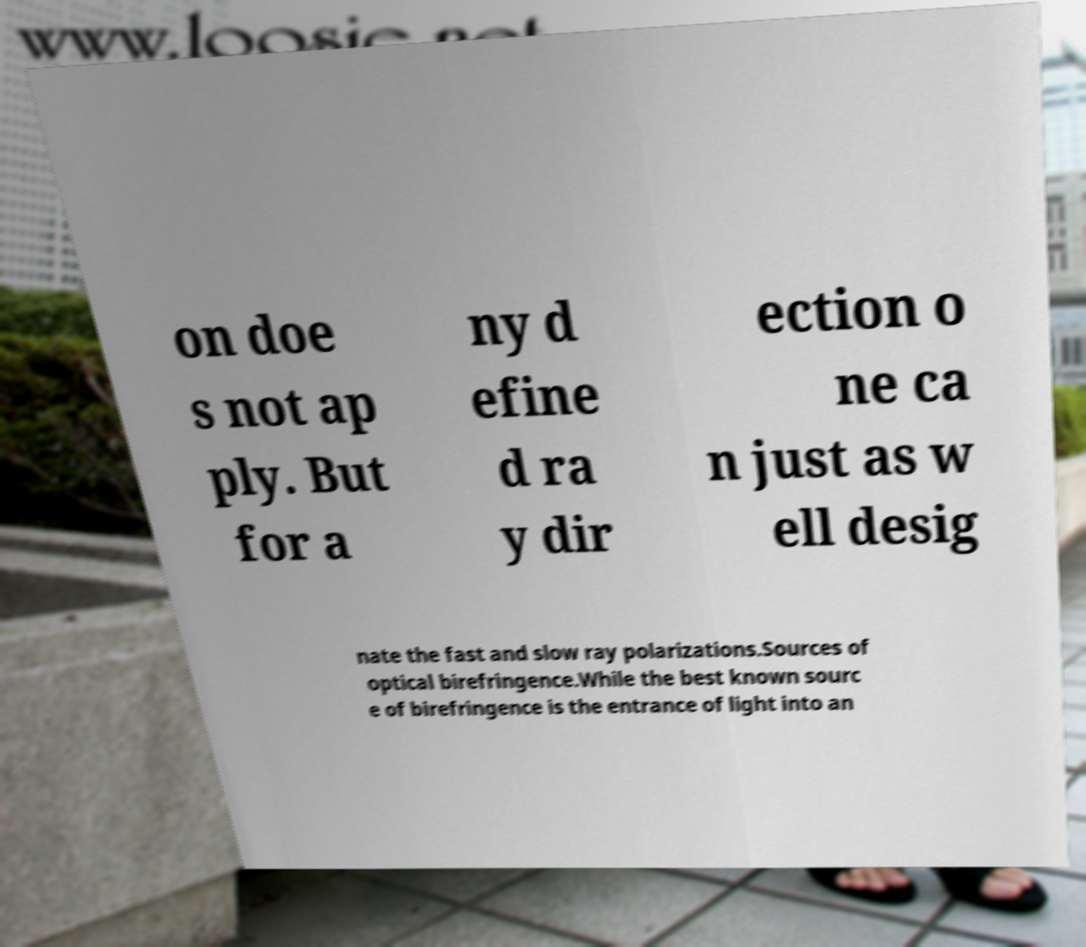For documentation purposes, I need the text within this image transcribed. Could you provide that? on doe s not ap ply. But for a ny d efine d ra y dir ection o ne ca n just as w ell desig nate the fast and slow ray polarizations.Sources of optical birefringence.While the best known sourc e of birefringence is the entrance of light into an 